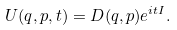<formula> <loc_0><loc_0><loc_500><loc_500>U ( q , p , t ) = D ( q , p ) e ^ { i t I } .</formula> 